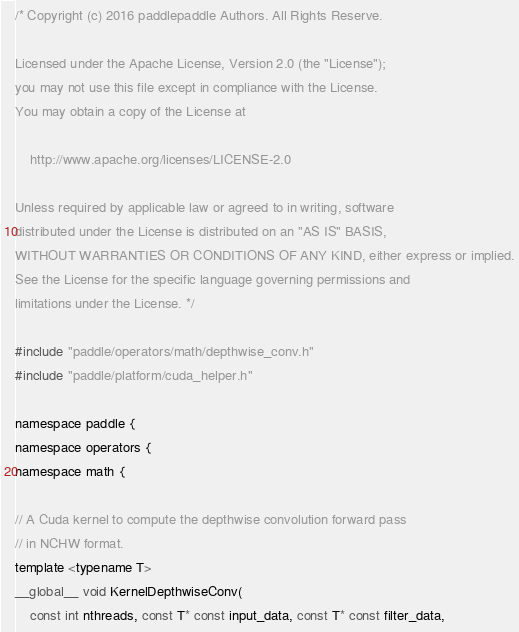Convert code to text. <code><loc_0><loc_0><loc_500><loc_500><_Cuda_>/* Copyright (c) 2016 paddlepaddle Authors. All Rights Reserve.

Licensed under the Apache License, Version 2.0 (the "License");
you may not use this file except in compliance with the License.
You may obtain a copy of the License at

    http://www.apache.org/licenses/LICENSE-2.0

Unless required by applicable law or agreed to in writing, software
distributed under the License is distributed on an "AS IS" BASIS,
WITHOUT WARRANTIES OR CONDITIONS OF ANY KIND, either express or implied.
See the License for the specific language governing permissions and
limitations under the License. */

#include "paddle/operators/math/depthwise_conv.h"
#include "paddle/platform/cuda_helper.h"

namespace paddle {
namespace operators {
namespace math {

// A Cuda kernel to compute the depthwise convolution forward pass
// in NCHW format.
template <typename T>
__global__ void KernelDepthwiseConv(
    const int nthreads, const T* const input_data, const T* const filter_data,</code> 